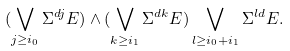<formula> <loc_0><loc_0><loc_500><loc_500>( \bigvee _ { j \geq i _ { 0 } } \Sigma ^ { d j } E ) \wedge ( \bigvee _ { k \geq i _ { 1 } } \Sigma ^ { d k } E ) \bigvee _ { l \geq i _ { 0 } + i _ { 1 } } \Sigma ^ { l d } E .</formula> 